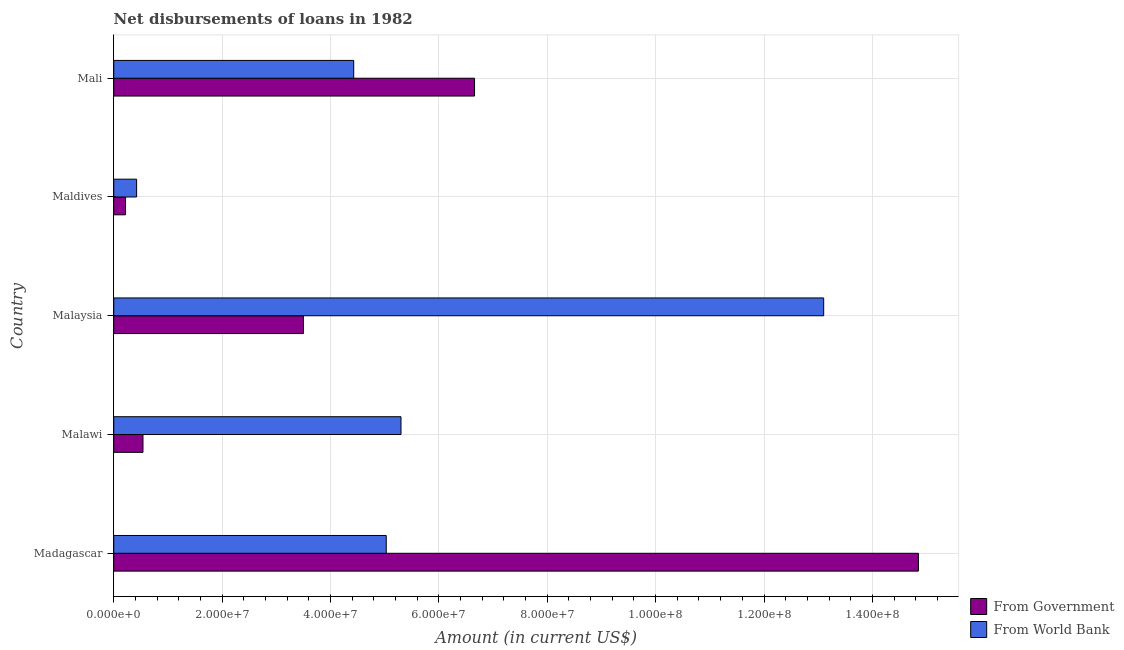Are the number of bars on each tick of the Y-axis equal?
Keep it short and to the point. Yes. How many bars are there on the 4th tick from the top?
Make the answer very short. 2. How many bars are there on the 2nd tick from the bottom?
Your response must be concise. 2. What is the label of the 5th group of bars from the top?
Offer a very short reply. Madagascar. In how many cases, is the number of bars for a given country not equal to the number of legend labels?
Your answer should be compact. 0. What is the net disbursements of loan from government in Malaysia?
Your answer should be compact. 3.50e+07. Across all countries, what is the maximum net disbursements of loan from world bank?
Your answer should be compact. 1.31e+08. Across all countries, what is the minimum net disbursements of loan from world bank?
Your response must be concise. 4.22e+06. In which country was the net disbursements of loan from government maximum?
Ensure brevity in your answer.  Madagascar. In which country was the net disbursements of loan from world bank minimum?
Keep it short and to the point. Maldives. What is the total net disbursements of loan from government in the graph?
Give a very brief answer. 2.58e+08. What is the difference between the net disbursements of loan from government in Malawi and that in Maldives?
Offer a terse response. 3.22e+06. What is the difference between the net disbursements of loan from government in Maldives and the net disbursements of loan from world bank in Malawi?
Offer a very short reply. -5.08e+07. What is the average net disbursements of loan from world bank per country?
Provide a succinct answer. 5.66e+07. What is the difference between the net disbursements of loan from government and net disbursements of loan from world bank in Mali?
Offer a terse response. 2.23e+07. What is the ratio of the net disbursements of loan from government in Maldives to that in Mali?
Your answer should be very brief. 0.03. Is the difference between the net disbursements of loan from world bank in Malawi and Mali greater than the difference between the net disbursements of loan from government in Malawi and Mali?
Ensure brevity in your answer.  Yes. What is the difference between the highest and the second highest net disbursements of loan from government?
Ensure brevity in your answer.  8.19e+07. What is the difference between the highest and the lowest net disbursements of loan from government?
Keep it short and to the point. 1.46e+08. Is the sum of the net disbursements of loan from world bank in Madagascar and Malawi greater than the maximum net disbursements of loan from government across all countries?
Make the answer very short. No. What does the 1st bar from the top in Mali represents?
Your answer should be compact. From World Bank. What does the 1st bar from the bottom in Malaysia represents?
Your answer should be very brief. From Government. Are all the bars in the graph horizontal?
Offer a terse response. Yes. How many countries are there in the graph?
Give a very brief answer. 5. What is the difference between two consecutive major ticks on the X-axis?
Your answer should be very brief. 2.00e+07. Does the graph contain grids?
Make the answer very short. Yes. How many legend labels are there?
Offer a terse response. 2. What is the title of the graph?
Make the answer very short. Net disbursements of loans in 1982. Does "Frequency of shipment arrival" appear as one of the legend labels in the graph?
Give a very brief answer. No. What is the Amount (in current US$) of From Government in Madagascar?
Provide a succinct answer. 1.48e+08. What is the Amount (in current US$) of From World Bank in Madagascar?
Your answer should be compact. 5.03e+07. What is the Amount (in current US$) in From Government in Malawi?
Keep it short and to the point. 5.40e+06. What is the Amount (in current US$) of From World Bank in Malawi?
Make the answer very short. 5.30e+07. What is the Amount (in current US$) of From Government in Malaysia?
Make the answer very short. 3.50e+07. What is the Amount (in current US$) of From World Bank in Malaysia?
Ensure brevity in your answer.  1.31e+08. What is the Amount (in current US$) of From Government in Maldives?
Offer a terse response. 2.18e+06. What is the Amount (in current US$) in From World Bank in Maldives?
Give a very brief answer. 4.22e+06. What is the Amount (in current US$) in From Government in Mali?
Your response must be concise. 6.66e+07. What is the Amount (in current US$) of From World Bank in Mali?
Keep it short and to the point. 4.43e+07. Across all countries, what is the maximum Amount (in current US$) of From Government?
Make the answer very short. 1.48e+08. Across all countries, what is the maximum Amount (in current US$) of From World Bank?
Your response must be concise. 1.31e+08. Across all countries, what is the minimum Amount (in current US$) of From Government?
Your response must be concise. 2.18e+06. Across all countries, what is the minimum Amount (in current US$) in From World Bank?
Provide a short and direct response. 4.22e+06. What is the total Amount (in current US$) of From Government in the graph?
Ensure brevity in your answer.  2.58e+08. What is the total Amount (in current US$) in From World Bank in the graph?
Provide a succinct answer. 2.83e+08. What is the difference between the Amount (in current US$) of From Government in Madagascar and that in Malawi?
Make the answer very short. 1.43e+08. What is the difference between the Amount (in current US$) of From World Bank in Madagascar and that in Malawi?
Offer a very short reply. -2.72e+06. What is the difference between the Amount (in current US$) in From Government in Madagascar and that in Malaysia?
Your answer should be very brief. 1.13e+08. What is the difference between the Amount (in current US$) of From World Bank in Madagascar and that in Malaysia?
Keep it short and to the point. -8.07e+07. What is the difference between the Amount (in current US$) in From Government in Madagascar and that in Maldives?
Ensure brevity in your answer.  1.46e+08. What is the difference between the Amount (in current US$) of From World Bank in Madagascar and that in Maldives?
Offer a terse response. 4.61e+07. What is the difference between the Amount (in current US$) of From Government in Madagascar and that in Mali?
Your answer should be compact. 8.19e+07. What is the difference between the Amount (in current US$) in From World Bank in Madagascar and that in Mali?
Your answer should be compact. 6.00e+06. What is the difference between the Amount (in current US$) of From Government in Malawi and that in Malaysia?
Your answer should be compact. -2.96e+07. What is the difference between the Amount (in current US$) of From World Bank in Malawi and that in Malaysia?
Give a very brief answer. -7.80e+07. What is the difference between the Amount (in current US$) in From Government in Malawi and that in Maldives?
Give a very brief answer. 3.22e+06. What is the difference between the Amount (in current US$) in From World Bank in Malawi and that in Maldives?
Your answer should be compact. 4.88e+07. What is the difference between the Amount (in current US$) in From Government in Malawi and that in Mali?
Offer a terse response. -6.12e+07. What is the difference between the Amount (in current US$) of From World Bank in Malawi and that in Mali?
Your response must be concise. 8.73e+06. What is the difference between the Amount (in current US$) in From Government in Malaysia and that in Maldives?
Provide a short and direct response. 3.28e+07. What is the difference between the Amount (in current US$) in From World Bank in Malaysia and that in Maldives?
Provide a short and direct response. 1.27e+08. What is the difference between the Amount (in current US$) of From Government in Malaysia and that in Mali?
Your answer should be compact. -3.16e+07. What is the difference between the Amount (in current US$) in From World Bank in Malaysia and that in Mali?
Your answer should be very brief. 8.67e+07. What is the difference between the Amount (in current US$) in From Government in Maldives and that in Mali?
Make the answer very short. -6.44e+07. What is the difference between the Amount (in current US$) in From World Bank in Maldives and that in Mali?
Ensure brevity in your answer.  -4.01e+07. What is the difference between the Amount (in current US$) of From Government in Madagascar and the Amount (in current US$) of From World Bank in Malawi?
Offer a very short reply. 9.55e+07. What is the difference between the Amount (in current US$) of From Government in Madagascar and the Amount (in current US$) of From World Bank in Malaysia?
Your response must be concise. 1.75e+07. What is the difference between the Amount (in current US$) in From Government in Madagascar and the Amount (in current US$) in From World Bank in Maldives?
Offer a very short reply. 1.44e+08. What is the difference between the Amount (in current US$) in From Government in Madagascar and the Amount (in current US$) in From World Bank in Mali?
Keep it short and to the point. 1.04e+08. What is the difference between the Amount (in current US$) in From Government in Malawi and the Amount (in current US$) in From World Bank in Malaysia?
Provide a succinct answer. -1.26e+08. What is the difference between the Amount (in current US$) of From Government in Malawi and the Amount (in current US$) of From World Bank in Maldives?
Provide a succinct answer. 1.17e+06. What is the difference between the Amount (in current US$) in From Government in Malawi and the Amount (in current US$) in From World Bank in Mali?
Ensure brevity in your answer.  -3.89e+07. What is the difference between the Amount (in current US$) of From Government in Malaysia and the Amount (in current US$) of From World Bank in Maldives?
Ensure brevity in your answer.  3.08e+07. What is the difference between the Amount (in current US$) of From Government in Malaysia and the Amount (in current US$) of From World Bank in Mali?
Your answer should be compact. -9.28e+06. What is the difference between the Amount (in current US$) of From Government in Maldives and the Amount (in current US$) of From World Bank in Mali?
Give a very brief answer. -4.21e+07. What is the average Amount (in current US$) of From Government per country?
Your answer should be very brief. 5.15e+07. What is the average Amount (in current US$) in From World Bank per country?
Give a very brief answer. 5.66e+07. What is the difference between the Amount (in current US$) of From Government and Amount (in current US$) of From World Bank in Madagascar?
Provide a short and direct response. 9.82e+07. What is the difference between the Amount (in current US$) in From Government and Amount (in current US$) in From World Bank in Malawi?
Provide a succinct answer. -4.76e+07. What is the difference between the Amount (in current US$) of From Government and Amount (in current US$) of From World Bank in Malaysia?
Offer a very short reply. -9.60e+07. What is the difference between the Amount (in current US$) in From Government and Amount (in current US$) in From World Bank in Maldives?
Your answer should be very brief. -2.04e+06. What is the difference between the Amount (in current US$) of From Government and Amount (in current US$) of From World Bank in Mali?
Your answer should be very brief. 2.23e+07. What is the ratio of the Amount (in current US$) of From Government in Madagascar to that in Malawi?
Your answer should be very brief. 27.52. What is the ratio of the Amount (in current US$) of From World Bank in Madagascar to that in Malawi?
Give a very brief answer. 0.95. What is the ratio of the Amount (in current US$) of From Government in Madagascar to that in Malaysia?
Give a very brief answer. 4.24. What is the ratio of the Amount (in current US$) of From World Bank in Madagascar to that in Malaysia?
Your answer should be very brief. 0.38. What is the ratio of the Amount (in current US$) in From Government in Madagascar to that in Maldives?
Ensure brevity in your answer.  68.12. What is the ratio of the Amount (in current US$) in From World Bank in Madagascar to that in Maldives?
Ensure brevity in your answer.  11.91. What is the ratio of the Amount (in current US$) of From Government in Madagascar to that in Mali?
Offer a terse response. 2.23. What is the ratio of the Amount (in current US$) in From World Bank in Madagascar to that in Mali?
Keep it short and to the point. 1.14. What is the ratio of the Amount (in current US$) in From Government in Malawi to that in Malaysia?
Give a very brief answer. 0.15. What is the ratio of the Amount (in current US$) in From World Bank in Malawi to that in Malaysia?
Offer a terse response. 0.4. What is the ratio of the Amount (in current US$) in From Government in Malawi to that in Maldives?
Give a very brief answer. 2.48. What is the ratio of the Amount (in current US$) of From World Bank in Malawi to that in Maldives?
Keep it short and to the point. 12.56. What is the ratio of the Amount (in current US$) of From Government in Malawi to that in Mali?
Offer a terse response. 0.08. What is the ratio of the Amount (in current US$) in From World Bank in Malawi to that in Mali?
Give a very brief answer. 1.2. What is the ratio of the Amount (in current US$) of From Government in Malaysia to that in Maldives?
Offer a very short reply. 16.06. What is the ratio of the Amount (in current US$) in From World Bank in Malaysia to that in Maldives?
Offer a very short reply. 31.03. What is the ratio of the Amount (in current US$) of From Government in Malaysia to that in Mali?
Keep it short and to the point. 0.53. What is the ratio of the Amount (in current US$) in From World Bank in Malaysia to that in Mali?
Provide a succinct answer. 2.96. What is the ratio of the Amount (in current US$) in From Government in Maldives to that in Mali?
Your answer should be compact. 0.03. What is the ratio of the Amount (in current US$) in From World Bank in Maldives to that in Mali?
Ensure brevity in your answer.  0.1. What is the difference between the highest and the second highest Amount (in current US$) of From Government?
Offer a very short reply. 8.19e+07. What is the difference between the highest and the second highest Amount (in current US$) of From World Bank?
Make the answer very short. 7.80e+07. What is the difference between the highest and the lowest Amount (in current US$) in From Government?
Your answer should be very brief. 1.46e+08. What is the difference between the highest and the lowest Amount (in current US$) in From World Bank?
Give a very brief answer. 1.27e+08. 